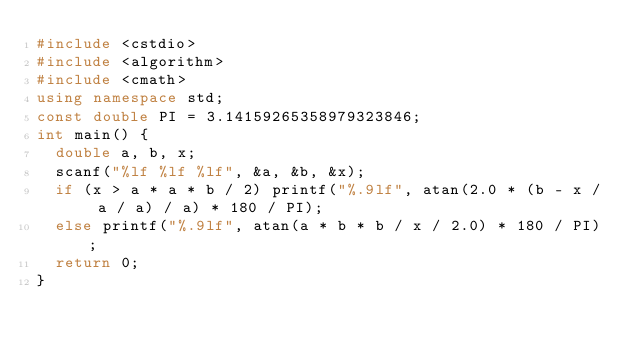Convert code to text. <code><loc_0><loc_0><loc_500><loc_500><_C++_>#include <cstdio>
#include <algorithm>
#include <cmath>
using namespace std;
const double PI = 3.14159265358979323846;
int main() {
	double a, b, x;
	scanf("%lf %lf %lf", &a, &b, &x);
	if (x > a * a * b / 2) printf("%.9lf", atan(2.0 * (b - x / a / a) / a) * 180 / PI);
	else printf("%.9lf", atan(a * b * b / x / 2.0) * 180 / PI);
	return 0;
}</code> 